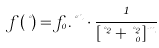Convert formula to latex. <formula><loc_0><loc_0><loc_500><loc_500>f ( \nu ) = f _ { 0 } . \nu ^ { n } \cdot \frac { 1 } { [ \nu ^ { 2 } + \nu _ { 0 } ^ { 2 } ] ^ { m } }</formula> 